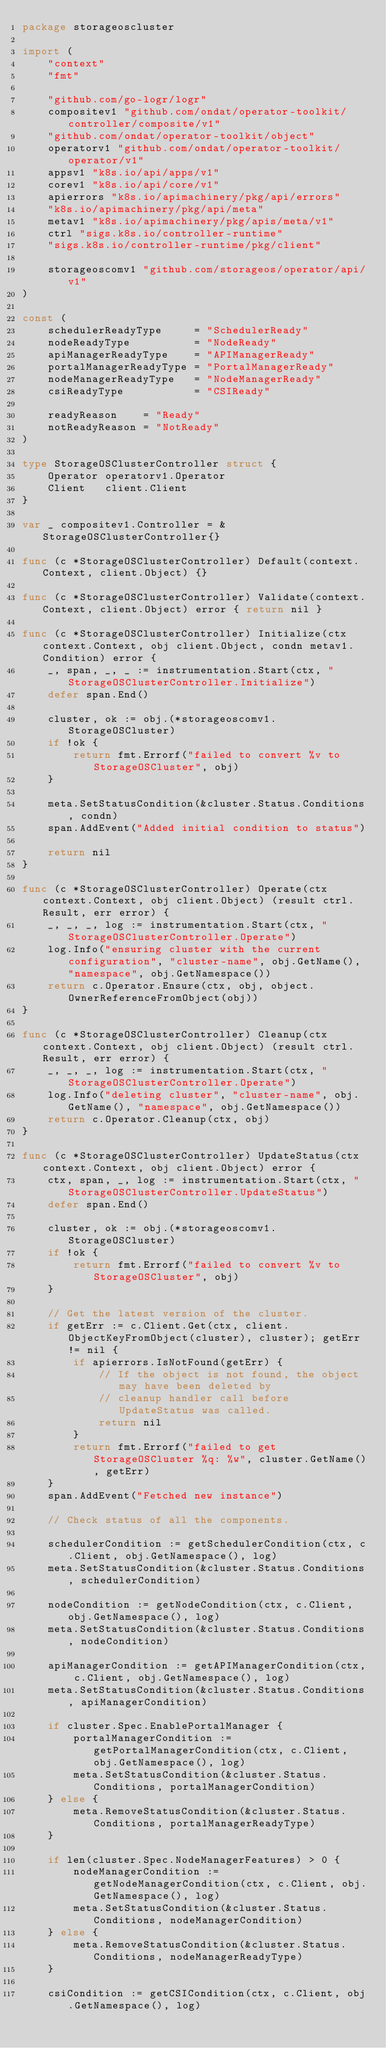Convert code to text. <code><loc_0><loc_0><loc_500><loc_500><_Go_>package storageoscluster

import (
	"context"
	"fmt"

	"github.com/go-logr/logr"
	compositev1 "github.com/ondat/operator-toolkit/controller/composite/v1"
	"github.com/ondat/operator-toolkit/object"
	operatorv1 "github.com/ondat/operator-toolkit/operator/v1"
	appsv1 "k8s.io/api/apps/v1"
	corev1 "k8s.io/api/core/v1"
	apierrors "k8s.io/apimachinery/pkg/api/errors"
	"k8s.io/apimachinery/pkg/api/meta"
	metav1 "k8s.io/apimachinery/pkg/apis/meta/v1"
	ctrl "sigs.k8s.io/controller-runtime"
	"sigs.k8s.io/controller-runtime/pkg/client"

	storageoscomv1 "github.com/storageos/operator/api/v1"
)

const (
	schedulerReadyType     = "SchedulerReady"
	nodeReadyType          = "NodeReady"
	apiManagerReadyType    = "APIManagerReady"
	portalManagerReadyType = "PortalManagerReady"
	nodeManagerReadyType   = "NodeManagerReady"
	csiReadyType           = "CSIReady"

	readyReason    = "Ready"
	notReadyReason = "NotReady"
)

type StorageOSClusterController struct {
	Operator operatorv1.Operator
	Client   client.Client
}

var _ compositev1.Controller = &StorageOSClusterController{}

func (c *StorageOSClusterController) Default(context.Context, client.Object) {}

func (c *StorageOSClusterController) Validate(context.Context, client.Object) error { return nil }

func (c *StorageOSClusterController) Initialize(ctx context.Context, obj client.Object, condn metav1.Condition) error {
	_, span, _, _ := instrumentation.Start(ctx, "StorageOSClusterController.Initialize")
	defer span.End()

	cluster, ok := obj.(*storageoscomv1.StorageOSCluster)
	if !ok {
		return fmt.Errorf("failed to convert %v to StorageOSCluster", obj)
	}

	meta.SetStatusCondition(&cluster.Status.Conditions, condn)
	span.AddEvent("Added initial condition to status")

	return nil
}

func (c *StorageOSClusterController) Operate(ctx context.Context, obj client.Object) (result ctrl.Result, err error) {
	_, _, _, log := instrumentation.Start(ctx, "StorageOSClusterController.Operate")
	log.Info("ensuring cluster with the current configuration", "cluster-name", obj.GetName(), "namespace", obj.GetNamespace())
	return c.Operator.Ensure(ctx, obj, object.OwnerReferenceFromObject(obj))
}

func (c *StorageOSClusterController) Cleanup(ctx context.Context, obj client.Object) (result ctrl.Result, err error) {
	_, _, _, log := instrumentation.Start(ctx, "StorageOSClusterController.Operate")
	log.Info("deleting cluster", "cluster-name", obj.GetName(), "namespace", obj.GetNamespace())
	return c.Operator.Cleanup(ctx, obj)
}

func (c *StorageOSClusterController) UpdateStatus(ctx context.Context, obj client.Object) error {
	ctx, span, _, log := instrumentation.Start(ctx, "StorageOSClusterController.UpdateStatus")
	defer span.End()

	cluster, ok := obj.(*storageoscomv1.StorageOSCluster)
	if !ok {
		return fmt.Errorf("failed to convert %v to StorageOSCluster", obj)
	}

	// Get the latest version of the cluster.
	if getErr := c.Client.Get(ctx, client.ObjectKeyFromObject(cluster), cluster); getErr != nil {
		if apierrors.IsNotFound(getErr) {
			// If the object is not found, the object may have been deleted by
			// cleanup handler call before UpdateStatus was called.
			return nil
		}
		return fmt.Errorf("failed to get StorageOSCluster %q: %w", cluster.GetName(), getErr)
	}
	span.AddEvent("Fetched new instance")

	// Check status of all the components.

	schedulerCondition := getSchedulerCondition(ctx, c.Client, obj.GetNamespace(), log)
	meta.SetStatusCondition(&cluster.Status.Conditions, schedulerCondition)

	nodeCondition := getNodeCondition(ctx, c.Client, obj.GetNamespace(), log)
	meta.SetStatusCondition(&cluster.Status.Conditions, nodeCondition)

	apiManagerCondition := getAPIManagerCondition(ctx, c.Client, obj.GetNamespace(), log)
	meta.SetStatusCondition(&cluster.Status.Conditions, apiManagerCondition)

	if cluster.Spec.EnablePortalManager {
		portalManagerCondition := getPortalManagerCondition(ctx, c.Client, obj.GetNamespace(), log)
		meta.SetStatusCondition(&cluster.Status.Conditions, portalManagerCondition)
	} else {
		meta.RemoveStatusCondition(&cluster.Status.Conditions, portalManagerReadyType)
	}

	if len(cluster.Spec.NodeManagerFeatures) > 0 {
		nodeManagerCondition := getNodeManagerCondition(ctx, c.Client, obj.GetNamespace(), log)
		meta.SetStatusCondition(&cluster.Status.Conditions, nodeManagerCondition)
	} else {
		meta.RemoveStatusCondition(&cluster.Status.Conditions, nodeManagerReadyType)
	}

	csiCondition := getCSICondition(ctx, c.Client, obj.GetNamespace(), log)</code> 